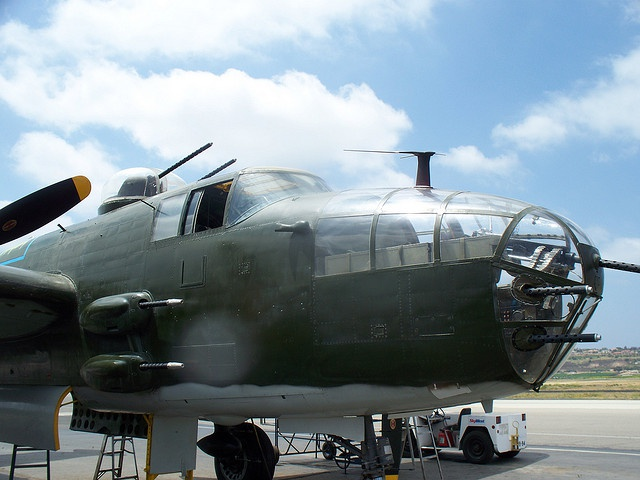Describe the objects in this image and their specific colors. I can see airplane in darkgray, black, gray, and lightgray tones and truck in darkgray, black, and gray tones in this image. 